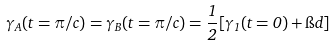Convert formula to latex. <formula><loc_0><loc_0><loc_500><loc_500>\gamma _ { A } ( t = \pi / c ) = \gamma _ { B } ( t = \pi / c ) = \frac { 1 } { 2 } [ \gamma _ { 1 } ( t = 0 ) + \i d ]</formula> 